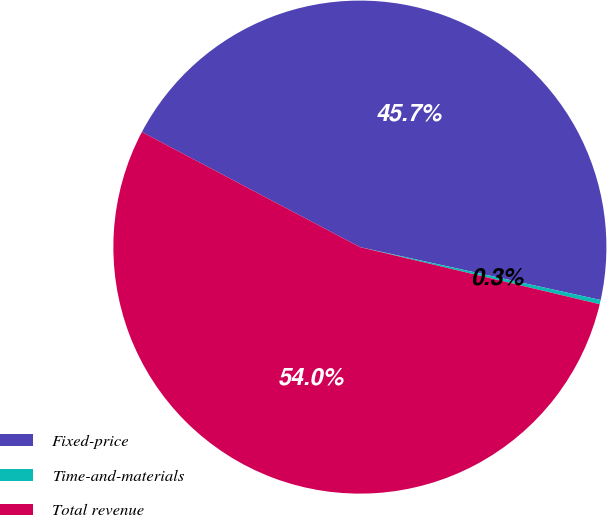Convert chart to OTSL. <chart><loc_0><loc_0><loc_500><loc_500><pie_chart><fcel>Fixed-price<fcel>Time-and-materials<fcel>Total revenue<nl><fcel>45.71%<fcel>0.28%<fcel>54.01%<nl></chart> 